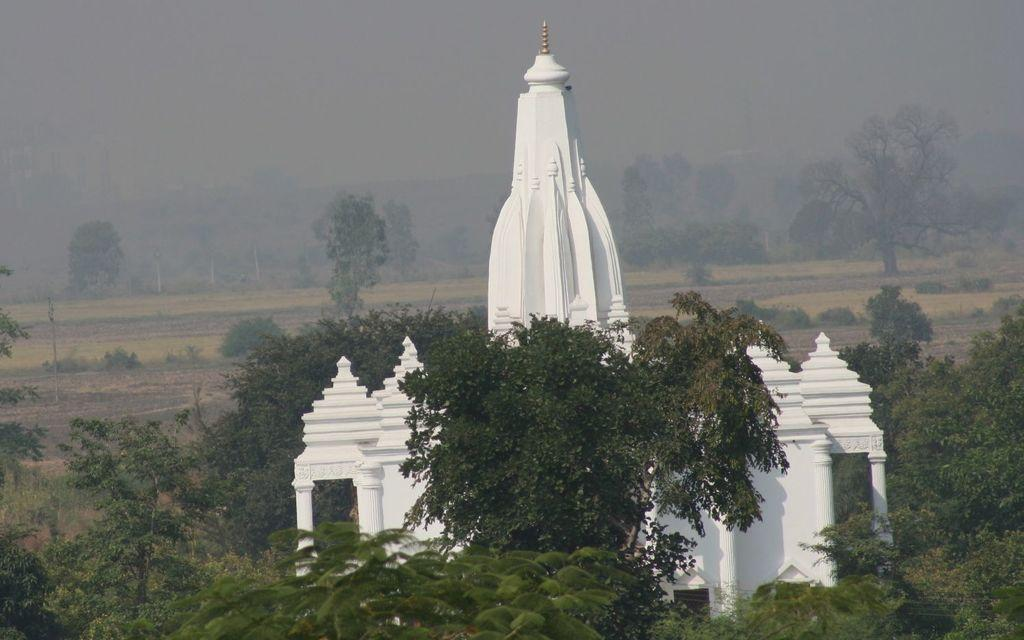What type of structure is in the image? There is a temple in the image. What is the color of the temple? The temple is white in color. What can be seen at the bottom of the image? There are plants and trees at the bottom of the image. What is visible in the background of the image? The ground is visible in the background of the image. What type of writing can be seen on the temple walls, and what color is the ink used? There is no writing or ink visible on the temple walls in the image. 